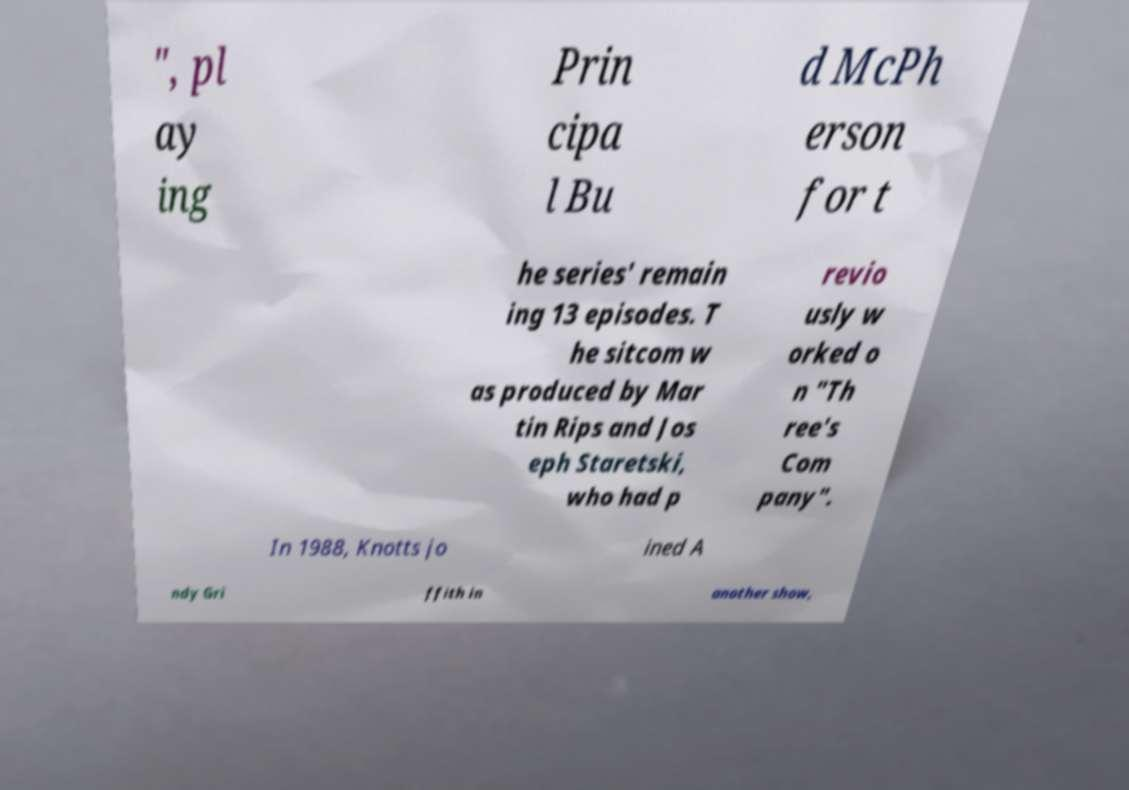Could you extract and type out the text from this image? ", pl ay ing Prin cipa l Bu d McPh erson for t he series' remain ing 13 episodes. T he sitcom w as produced by Mar tin Rips and Jos eph Staretski, who had p revio usly w orked o n "Th ree's Com pany". In 1988, Knotts jo ined A ndy Gri ffith in another show, 